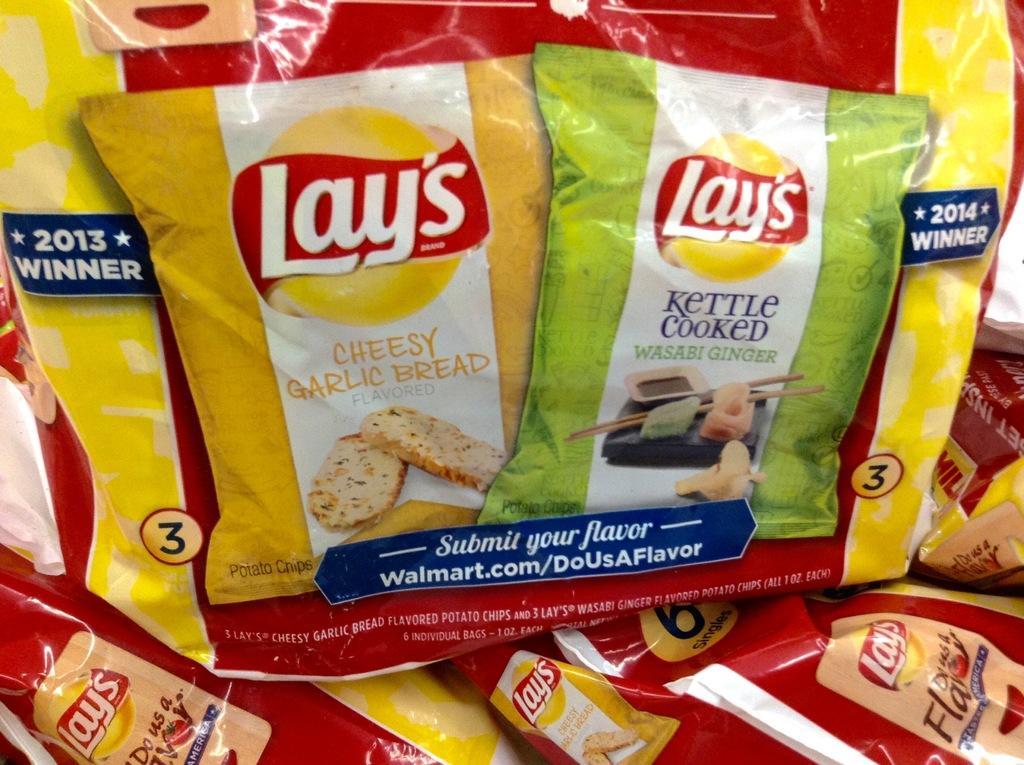Describe this image in one or two sentences. In this picture we can see packets. 